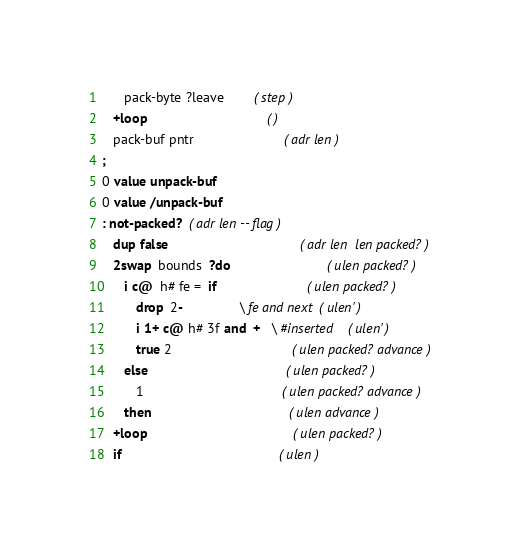<code> <loc_0><loc_0><loc_500><loc_500><_Forth_>      pack-byte ?leave   		( step )
   +loop                                ( )
   pack-buf pntr                        ( adr len )
;
0 value unpack-buf
0 value /unpack-buf
: not-packed?  ( adr len -- flag )
   dup false                                   ( adr len  len packed? )
   2swap  bounds  ?do                          ( ulen packed? )
      i c@  h# fe =  if                        ( ulen packed? )
         drop  2-               \ fe and next  ( ulen' )
         i 1+ c@ h# 3f and  +   \ #inserted    ( ulen' )
         true 2                                ( ulen packed? advance )
      else                                     ( ulen packed? )
         1                                     ( ulen packed? advance )
      then                                     ( ulen advance )
   +loop                                       ( ulen packed? )
   if                                          ( ulen )</code> 